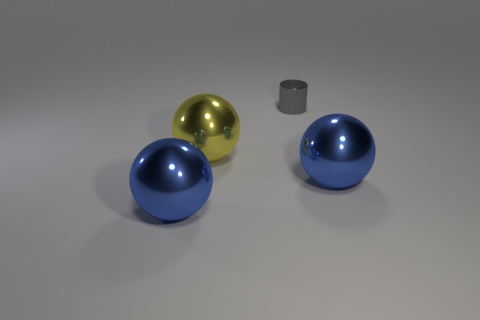Add 4 big yellow spheres. How many objects exist? 8 Subtract all cylinders. How many objects are left? 3 Add 4 gray shiny objects. How many gray shiny objects exist? 5 Subtract 0 green cylinders. How many objects are left? 4 Subtract all large yellow balls. Subtract all cyan rubber cubes. How many objects are left? 3 Add 1 small cylinders. How many small cylinders are left? 2 